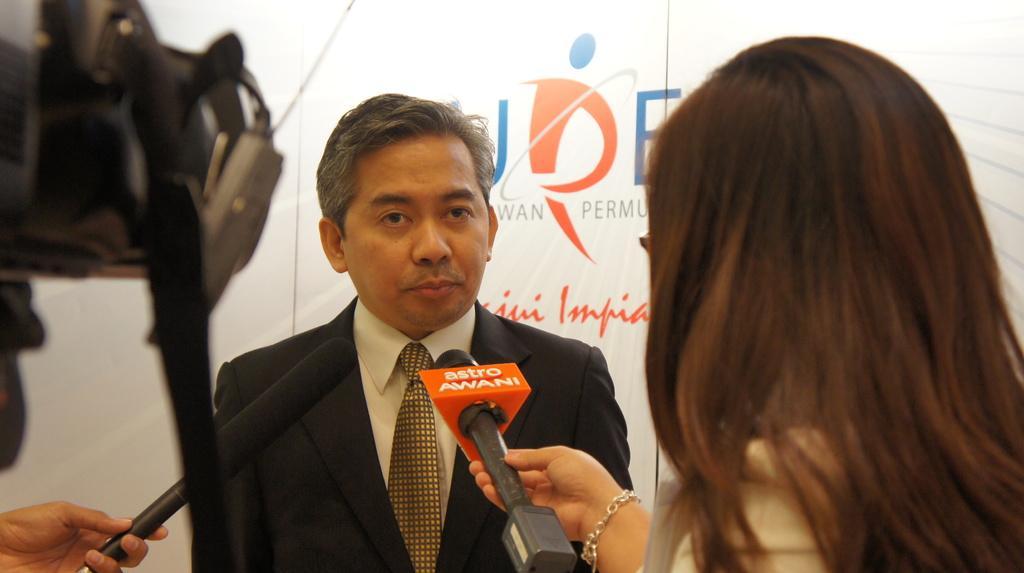In one or two sentences, can you explain what this image depicts? On the left side, there is a camera and a hand of a person holding this microphone. On the right side, there is a woman holding a microphone. In front of her, there is a person smiling and standing. In the background, there is a banner. 